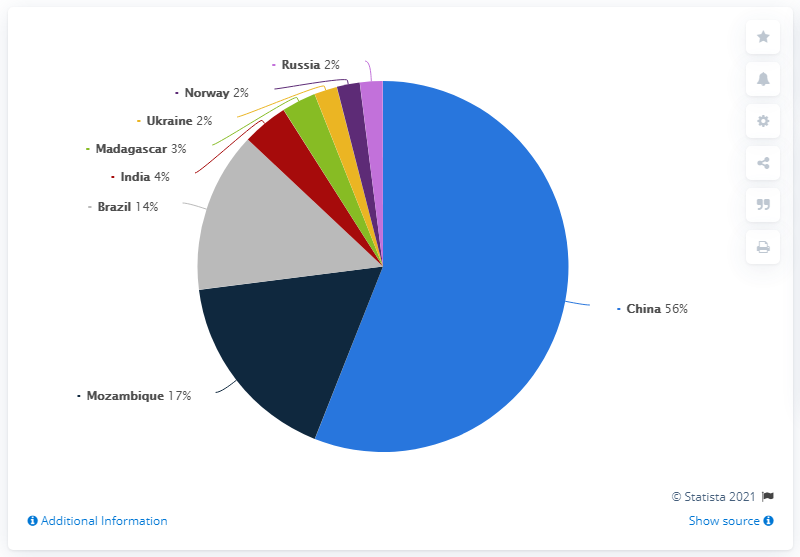List a handful of essential elements in this visual. There are 8 color segments. China supplied 56% of the global graphite supply in 2020. A significant number of countries have a supply of 2%. 